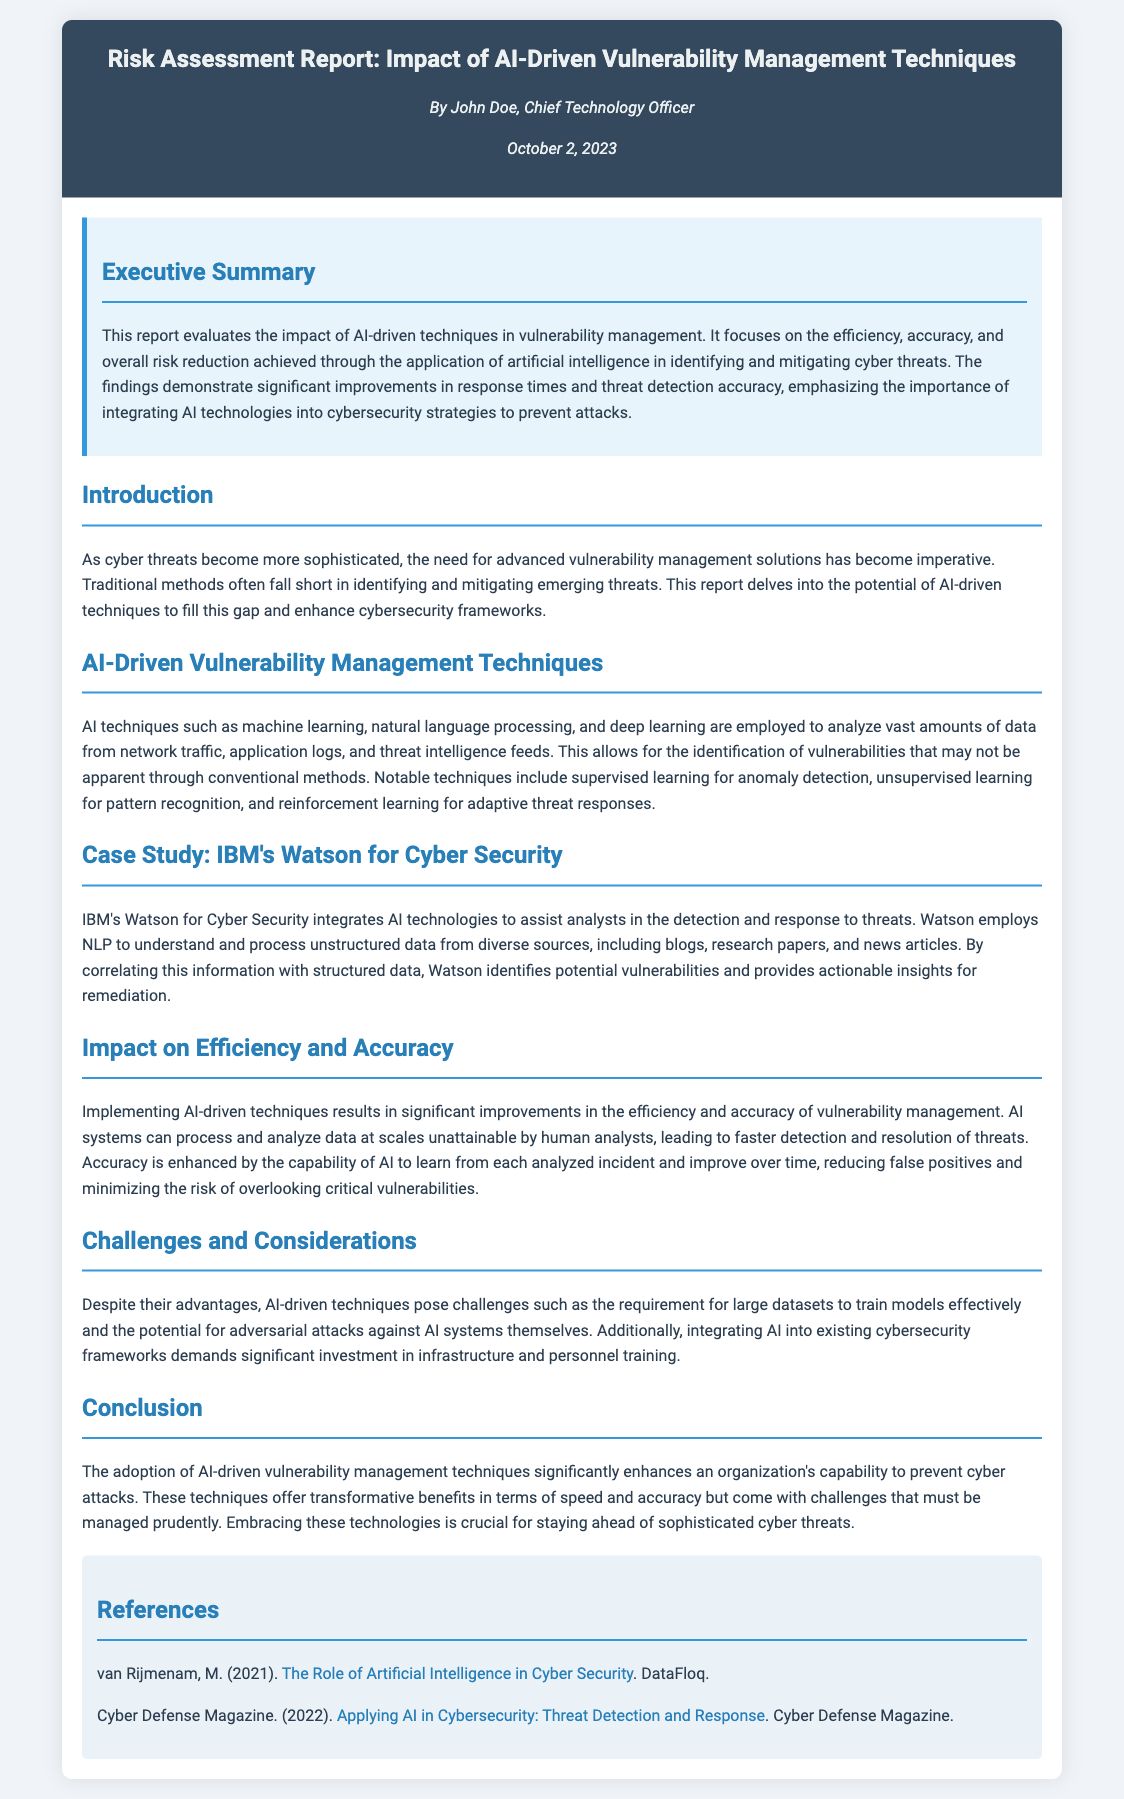What is the title of the report? The title of the report is provided in the header section of the document.
Answer: Risk Assessment Report: Impact of AI-Driven Vulnerability Management Techniques Who is the author of the report? The report specifies the author's name in the author-date section.
Answer: John Doe What date was the report published? The publication date is indicated in the author-date section.
Answer: October 2, 2023 What AI technology is mentioned as utilized by IBM's Watson for Cyber Security? The document specifies the technology used by Watson to process data in the case study section.
Answer: Natural language processing What significant improvement is noted in the use of AI techniques? The impact on vulnerability management is elaborated in the Impact on Efficiency and Accuracy section.
Answer: Efficiency and accuracy What are some challenges of using AI-driven techniques? The Challenges and Considerations section outlines the drawbacks faced when implementing these techniques.
Answer: Large datasets What is highlighted as a key benefit of AI-driven vulnerability management? The Conclusion section sums up the overall advantages of AI techniques in cybersecurity.
Answer: Speed and accuracy In which section is the case study about IBM's Watson found? The structure of the report indicates the placement of case studies among other sections.
Answer: AI-Driven Vulnerability Management Techniques How are AI techniques described in relation to emerging threats? The Introduction provides a perspective on the necessity of advanced methods for new cyber threats.
Answer: Imperative 